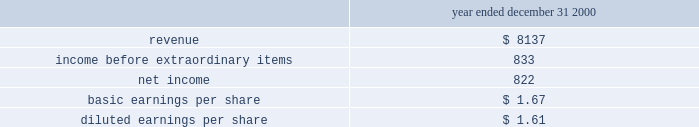Mw mamonal plant .
Approximately $ 77 million of the purchase price was allocated to goodwill and is being amortized over 32 years .
The termocandelaria power plant has been included in discontinued operations in the accompanying consolidated financial statements .
The table below presents supplemental unaudited pro forma operating results as if all of the acquisitions had occurred at the beginning of the periods shown ( in millions , except per share amounts ) .
No pro forma operating results are provided for 2001 , because the impact would not have been material .
The pro forma amounts include certain adjustments , primarily for depreciation and amortization based on the allocated purchase price and additional interest expense : year ended december 31 , 2000 .
The pro forma results are based upon assumptions and estimates that the company believes are reasonable .
The pro forma results do not purport to be indicative of the results that actually would have been obtained had the acquisitions occurred at the beginning of the periods shown , nor are they intended to be a projection of future results .
Discontinued operations effective january 1 , 2001 , the company adopted sfas no .
144 .
This statement addresses financial accounting and reporting for the impairment or disposal of long-lived assets .
Sfas no .
144 requires a component of an entity that either has been disposed of or is classified as held for sale to be reported as discontinued operations if certain conditions are met .
During the year , the company decided to exit certain of its businesses .
These businesses included power direct , geoutilities , termocandelaria , ib valley and several telecommunications businesses in brazil and the u.s .
The businesses were either disposed of or abandoned during the year or were classified as held for sale at december 31 , 2001 .
For those businesses disposed of or abandoned , the company determined that significant adverse changes in legal factors and/or the business climate , such as unfavorable market conditions and low tariffs , negatively affected the value of these assets .
The company has certain businesses that are held for sale , including termocandelaria .
The company has approved and committed to a plan to sell these assets , they are available for immediate sale , and a plan has been established to locate a buyer at a reasonable fair market value price .
The company believes it will sell these assets within one year and it is unlikely that significant changes will be made to the plan to sell .
At december 31 , 2001 , the assets and liabilities associated with the discontinued operations are segregated on the consolidated balance sheets .
A majority of the long-lived assets related to discontinued operations are for the termocandelaria competitive supply business located in colombia .
The revenues associated with the discontinued operations were $ 287 million , $ 74 million and $ 7 million for the years ended december 31 , 2001 , 2000 and 1999 , respectively .
The pretax losses associated with the discontinued operations were $ 58 million , $ 31 million and $ 4 million for each of the years ended december 31 , 2001 , 2000 and 1999 , respectively .
The loss on disposal and impairment write-downs for those businesses held for sale , net of tax associated with the discontinued operations , was $ 145 million for the year ended december 31 , 2001. .
Disco losses improved by how much in 2001? 
Computations: ((58 - 31) * 1000000)
Answer: 27000000.0. 